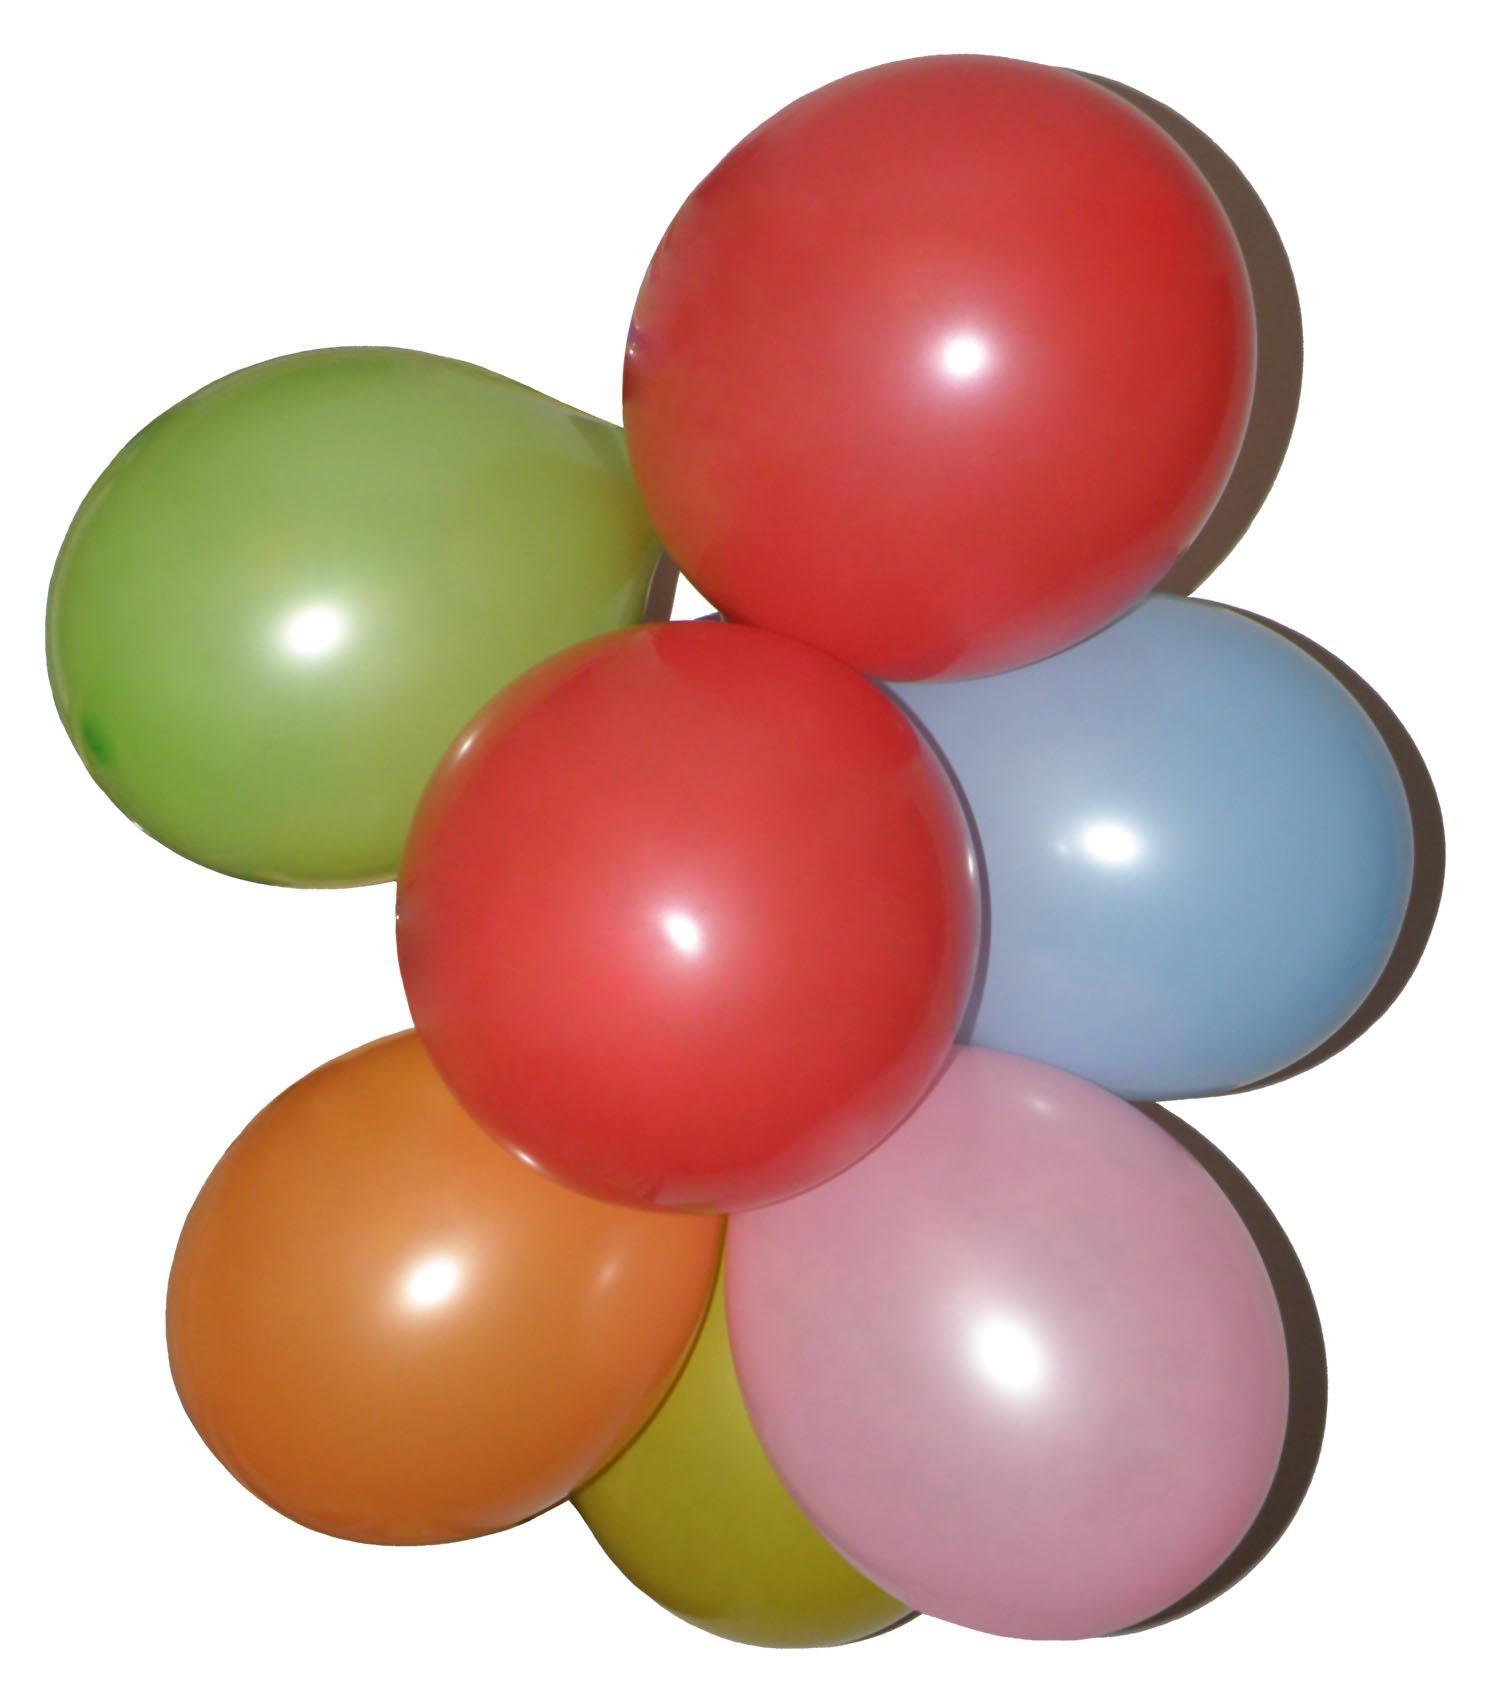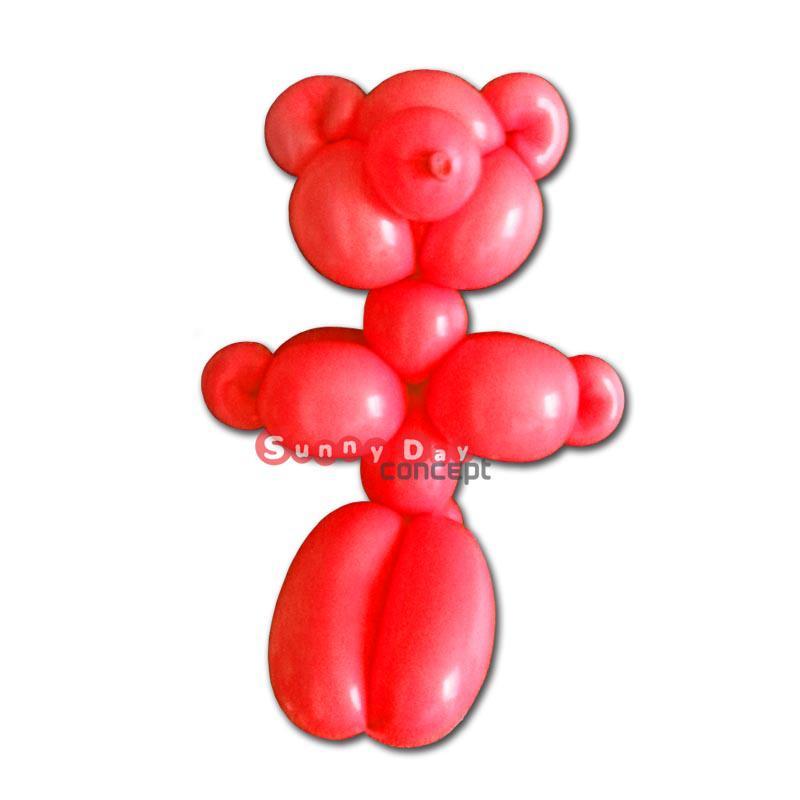The first image is the image on the left, the second image is the image on the right. Considering the images on both sides, is "The right-hand image features a single balloon animal." valid? Answer yes or no. Yes. 